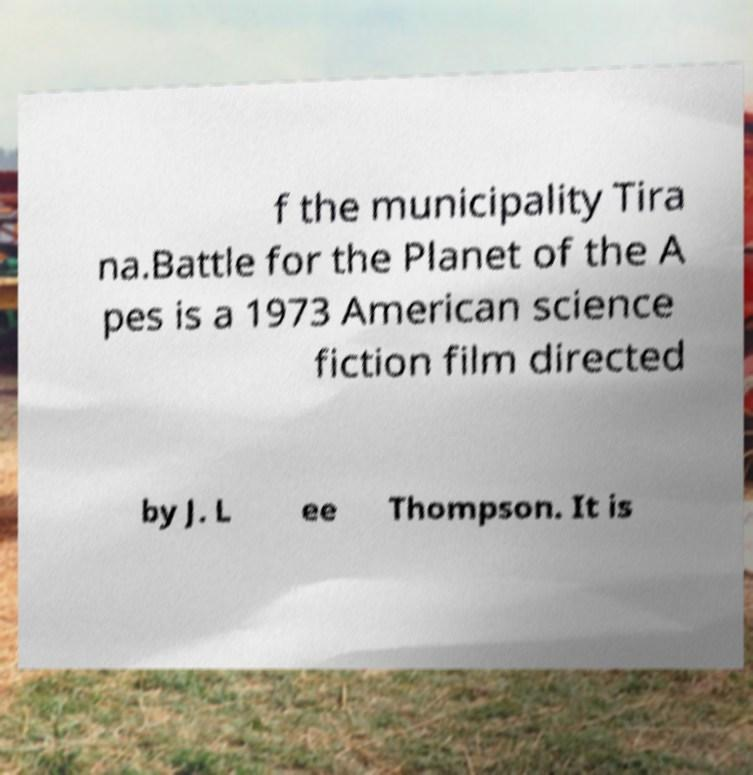Please read and relay the text visible in this image. What does it say? f the municipality Tira na.Battle for the Planet of the A pes is a 1973 American science fiction film directed by J. L ee Thompson. It is 